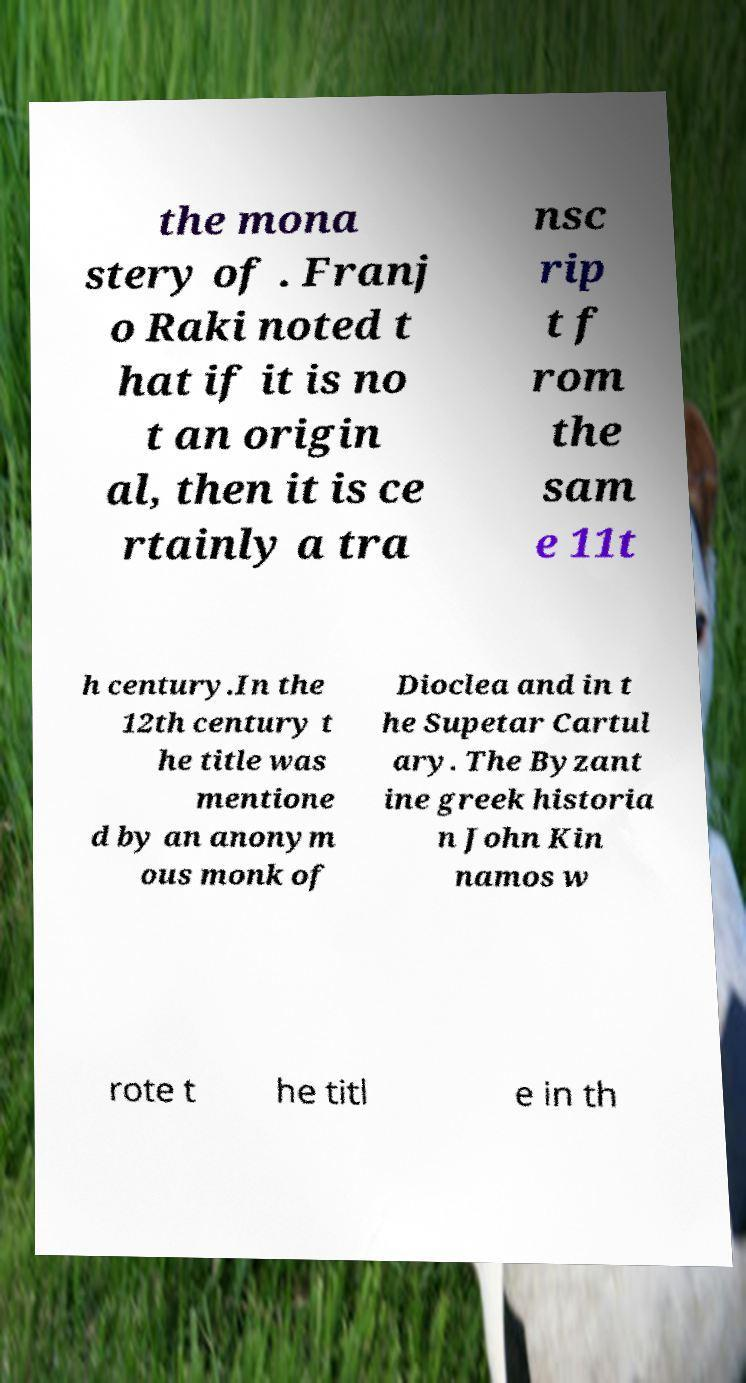For documentation purposes, I need the text within this image transcribed. Could you provide that? the mona stery of . Franj o Raki noted t hat if it is no t an origin al, then it is ce rtainly a tra nsc rip t f rom the sam e 11t h century.In the 12th century t he title was mentione d by an anonym ous monk of Dioclea and in t he Supetar Cartul ary. The Byzant ine greek historia n John Kin namos w rote t he titl e in th 